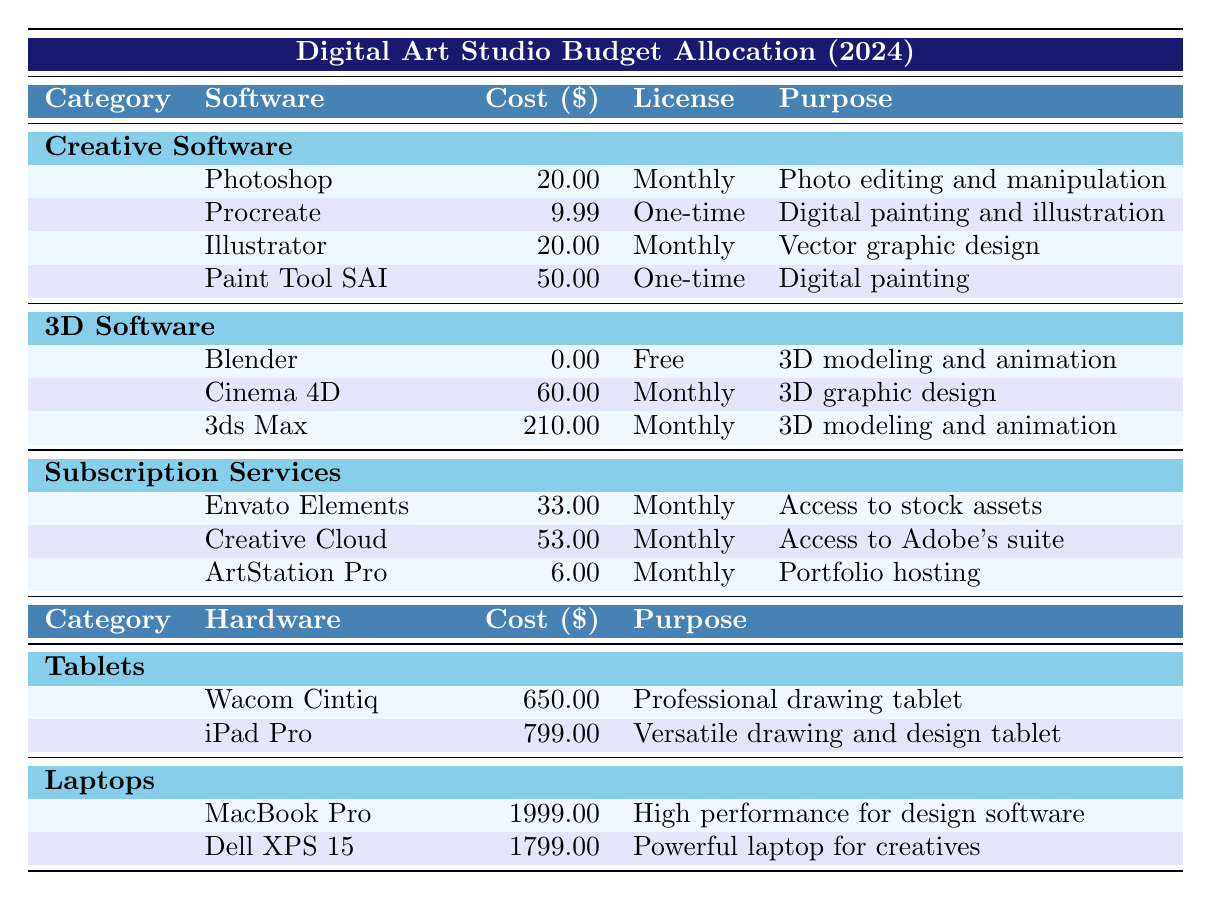What is the total cost of the Creative Software? The costs for the Creative Software are: Photoshop ($20), Procreate ($9.99), Illustrator ($20), and Paint Tool SAI ($50). Summing these up gives: 20 + 9.99 + 20 + 50 = $99.99.
Answer: $99.99 Which software has the highest cost? The highest cost software is 3ds Max at $210 per month. This can be determined by comparing the costs of all software listed.
Answer: 3ds Max Is Blender a paid software? Blender is listed as a free software with a cost of $0. This can be confirmed by its entry under the 3D Software category.
Answer: No What is the purpose of Procreate? Procreate's purpose is listed as "Digital painting and illustration," which can be found in its description in the table.
Answer: Digital painting and illustration What is the average cost of the laptops? The costs for the laptops are: MacBook Pro ($1999) and Dell XPS 15 ($1799). First, sum the costs: 1999 + 1799 = $3798. Then divide by the number of laptops (2): 3798 / 2 = $1899.
Answer: $1899 How much does the subscription service ArtStation Pro cost? The table indicates that ArtStation Pro costs $6 per month, which can be easily located in the Subscription Services section.
Answer: $6 If we consider only the monthly costs of software subscriptions, what is the total? The monthly costs of software subscriptions are: Envato Elements ($33), Creative Cloud ($53), ArtStation Pro ($6), Photoshop ($20), Illustrator ($20), Cinema 4D ($60), and 3ds Max ($210). Adding these gives: 33 + 53 + 6 + 20 + 20 + 60 + 210 = $402.
Answer: $402 Which vendor provides the most software listed in the table? By examining the vendors for all the software, Adobe appears three times (Photoshop, Illustrator, and Creative Cloud), whereas other vendors appear less frequently. Therefore, Adobe provides the most software.
Answer: Adobe Is the Wacom Cintiq a subscription-based hardware? The Wacom Cintiq has a one-time purchase cost of $650, which is not consistent with being a subscription-based hardware. Therefore, it is not subscription-based.
Answer: No What is the combined cost of all Creative Software and Hardware? The total cost of Creative Software is $99.99, and the total cost of Hardware (Wacom Cintiq: $650, iPad Pro: $799, MacBook Pro: $1999, Dell XPS 15: $1799) is: 650 + 799 + 1999 + 1799 = $4247. Combining both totals gives $99.99 + $4247 = $4346.99.
Answer: $4346.99 